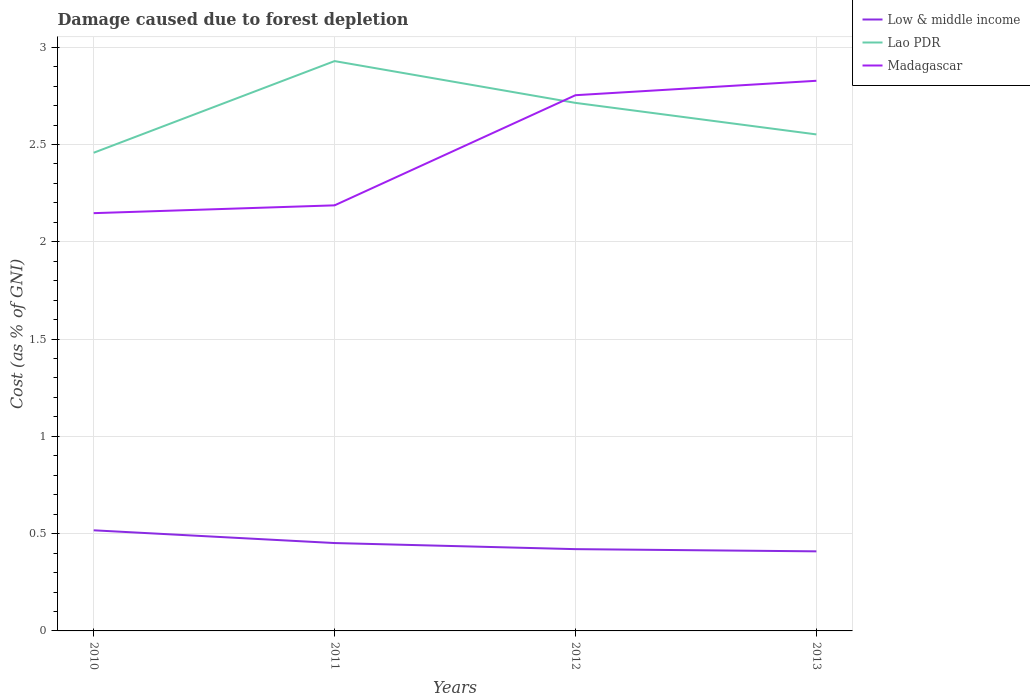How many different coloured lines are there?
Your response must be concise. 3. Does the line corresponding to Low & middle income intersect with the line corresponding to Madagascar?
Give a very brief answer. No. Is the number of lines equal to the number of legend labels?
Provide a short and direct response. Yes. Across all years, what is the maximum cost of damage caused due to forest depletion in Low & middle income?
Keep it short and to the point. 0.41. What is the total cost of damage caused due to forest depletion in Low & middle income in the graph?
Ensure brevity in your answer.  0.04. What is the difference between the highest and the second highest cost of damage caused due to forest depletion in Low & middle income?
Provide a succinct answer. 0.11. What is the difference between the highest and the lowest cost of damage caused due to forest depletion in Lao PDR?
Your answer should be compact. 2. Is the cost of damage caused due to forest depletion in Lao PDR strictly greater than the cost of damage caused due to forest depletion in Low & middle income over the years?
Keep it short and to the point. No. How many lines are there?
Keep it short and to the point. 3. What is the difference between two consecutive major ticks on the Y-axis?
Offer a terse response. 0.5. Does the graph contain grids?
Make the answer very short. Yes. Where does the legend appear in the graph?
Your answer should be very brief. Top right. How many legend labels are there?
Give a very brief answer. 3. What is the title of the graph?
Offer a terse response. Damage caused due to forest depletion. What is the label or title of the X-axis?
Your response must be concise. Years. What is the label or title of the Y-axis?
Provide a succinct answer. Cost (as % of GNI). What is the Cost (as % of GNI) in Low & middle income in 2010?
Offer a very short reply. 0.52. What is the Cost (as % of GNI) of Lao PDR in 2010?
Your response must be concise. 2.46. What is the Cost (as % of GNI) in Madagascar in 2010?
Ensure brevity in your answer.  2.15. What is the Cost (as % of GNI) in Low & middle income in 2011?
Provide a succinct answer. 0.45. What is the Cost (as % of GNI) in Lao PDR in 2011?
Your response must be concise. 2.93. What is the Cost (as % of GNI) of Madagascar in 2011?
Your answer should be very brief. 2.19. What is the Cost (as % of GNI) of Low & middle income in 2012?
Give a very brief answer. 0.42. What is the Cost (as % of GNI) of Lao PDR in 2012?
Offer a terse response. 2.71. What is the Cost (as % of GNI) in Madagascar in 2012?
Give a very brief answer. 2.75. What is the Cost (as % of GNI) in Low & middle income in 2013?
Ensure brevity in your answer.  0.41. What is the Cost (as % of GNI) of Lao PDR in 2013?
Your answer should be very brief. 2.55. What is the Cost (as % of GNI) of Madagascar in 2013?
Provide a short and direct response. 2.83. Across all years, what is the maximum Cost (as % of GNI) of Low & middle income?
Offer a very short reply. 0.52. Across all years, what is the maximum Cost (as % of GNI) of Lao PDR?
Give a very brief answer. 2.93. Across all years, what is the maximum Cost (as % of GNI) in Madagascar?
Your response must be concise. 2.83. Across all years, what is the minimum Cost (as % of GNI) in Low & middle income?
Your answer should be compact. 0.41. Across all years, what is the minimum Cost (as % of GNI) of Lao PDR?
Give a very brief answer. 2.46. Across all years, what is the minimum Cost (as % of GNI) of Madagascar?
Keep it short and to the point. 2.15. What is the total Cost (as % of GNI) in Low & middle income in the graph?
Ensure brevity in your answer.  1.8. What is the total Cost (as % of GNI) in Lao PDR in the graph?
Offer a very short reply. 10.65. What is the total Cost (as % of GNI) in Madagascar in the graph?
Provide a short and direct response. 9.92. What is the difference between the Cost (as % of GNI) in Low & middle income in 2010 and that in 2011?
Give a very brief answer. 0.07. What is the difference between the Cost (as % of GNI) of Lao PDR in 2010 and that in 2011?
Make the answer very short. -0.47. What is the difference between the Cost (as % of GNI) in Madagascar in 2010 and that in 2011?
Provide a short and direct response. -0.04. What is the difference between the Cost (as % of GNI) in Low & middle income in 2010 and that in 2012?
Make the answer very short. 0.1. What is the difference between the Cost (as % of GNI) of Lao PDR in 2010 and that in 2012?
Provide a short and direct response. -0.26. What is the difference between the Cost (as % of GNI) of Madagascar in 2010 and that in 2012?
Make the answer very short. -0.61. What is the difference between the Cost (as % of GNI) of Low & middle income in 2010 and that in 2013?
Give a very brief answer. 0.11. What is the difference between the Cost (as % of GNI) in Lao PDR in 2010 and that in 2013?
Your answer should be compact. -0.09. What is the difference between the Cost (as % of GNI) in Madagascar in 2010 and that in 2013?
Keep it short and to the point. -0.68. What is the difference between the Cost (as % of GNI) of Low & middle income in 2011 and that in 2012?
Your answer should be very brief. 0.03. What is the difference between the Cost (as % of GNI) of Lao PDR in 2011 and that in 2012?
Provide a succinct answer. 0.21. What is the difference between the Cost (as % of GNI) of Madagascar in 2011 and that in 2012?
Offer a terse response. -0.57. What is the difference between the Cost (as % of GNI) in Low & middle income in 2011 and that in 2013?
Your answer should be very brief. 0.04. What is the difference between the Cost (as % of GNI) in Lao PDR in 2011 and that in 2013?
Your response must be concise. 0.38. What is the difference between the Cost (as % of GNI) in Madagascar in 2011 and that in 2013?
Provide a succinct answer. -0.64. What is the difference between the Cost (as % of GNI) of Low & middle income in 2012 and that in 2013?
Ensure brevity in your answer.  0.01. What is the difference between the Cost (as % of GNI) of Lao PDR in 2012 and that in 2013?
Keep it short and to the point. 0.16. What is the difference between the Cost (as % of GNI) of Madagascar in 2012 and that in 2013?
Ensure brevity in your answer.  -0.07. What is the difference between the Cost (as % of GNI) of Low & middle income in 2010 and the Cost (as % of GNI) of Lao PDR in 2011?
Give a very brief answer. -2.41. What is the difference between the Cost (as % of GNI) in Low & middle income in 2010 and the Cost (as % of GNI) in Madagascar in 2011?
Make the answer very short. -1.67. What is the difference between the Cost (as % of GNI) in Lao PDR in 2010 and the Cost (as % of GNI) in Madagascar in 2011?
Provide a succinct answer. 0.27. What is the difference between the Cost (as % of GNI) of Low & middle income in 2010 and the Cost (as % of GNI) of Lao PDR in 2012?
Your answer should be very brief. -2.2. What is the difference between the Cost (as % of GNI) of Low & middle income in 2010 and the Cost (as % of GNI) of Madagascar in 2012?
Offer a very short reply. -2.24. What is the difference between the Cost (as % of GNI) of Lao PDR in 2010 and the Cost (as % of GNI) of Madagascar in 2012?
Offer a terse response. -0.3. What is the difference between the Cost (as % of GNI) in Low & middle income in 2010 and the Cost (as % of GNI) in Lao PDR in 2013?
Your response must be concise. -2.03. What is the difference between the Cost (as % of GNI) of Low & middle income in 2010 and the Cost (as % of GNI) of Madagascar in 2013?
Provide a short and direct response. -2.31. What is the difference between the Cost (as % of GNI) in Lao PDR in 2010 and the Cost (as % of GNI) in Madagascar in 2013?
Provide a succinct answer. -0.37. What is the difference between the Cost (as % of GNI) in Low & middle income in 2011 and the Cost (as % of GNI) in Lao PDR in 2012?
Provide a succinct answer. -2.26. What is the difference between the Cost (as % of GNI) in Low & middle income in 2011 and the Cost (as % of GNI) in Madagascar in 2012?
Give a very brief answer. -2.3. What is the difference between the Cost (as % of GNI) of Lao PDR in 2011 and the Cost (as % of GNI) of Madagascar in 2012?
Offer a very short reply. 0.18. What is the difference between the Cost (as % of GNI) in Low & middle income in 2011 and the Cost (as % of GNI) in Lao PDR in 2013?
Your answer should be compact. -2.1. What is the difference between the Cost (as % of GNI) in Low & middle income in 2011 and the Cost (as % of GNI) in Madagascar in 2013?
Provide a short and direct response. -2.38. What is the difference between the Cost (as % of GNI) in Lao PDR in 2011 and the Cost (as % of GNI) in Madagascar in 2013?
Ensure brevity in your answer.  0.1. What is the difference between the Cost (as % of GNI) in Low & middle income in 2012 and the Cost (as % of GNI) in Lao PDR in 2013?
Offer a terse response. -2.13. What is the difference between the Cost (as % of GNI) of Low & middle income in 2012 and the Cost (as % of GNI) of Madagascar in 2013?
Provide a succinct answer. -2.41. What is the difference between the Cost (as % of GNI) of Lao PDR in 2012 and the Cost (as % of GNI) of Madagascar in 2013?
Keep it short and to the point. -0.11. What is the average Cost (as % of GNI) in Low & middle income per year?
Provide a succinct answer. 0.45. What is the average Cost (as % of GNI) in Lao PDR per year?
Ensure brevity in your answer.  2.66. What is the average Cost (as % of GNI) of Madagascar per year?
Your response must be concise. 2.48. In the year 2010, what is the difference between the Cost (as % of GNI) in Low & middle income and Cost (as % of GNI) in Lao PDR?
Provide a short and direct response. -1.94. In the year 2010, what is the difference between the Cost (as % of GNI) of Low & middle income and Cost (as % of GNI) of Madagascar?
Provide a short and direct response. -1.63. In the year 2010, what is the difference between the Cost (as % of GNI) of Lao PDR and Cost (as % of GNI) of Madagascar?
Your answer should be very brief. 0.31. In the year 2011, what is the difference between the Cost (as % of GNI) in Low & middle income and Cost (as % of GNI) in Lao PDR?
Your answer should be compact. -2.48. In the year 2011, what is the difference between the Cost (as % of GNI) of Low & middle income and Cost (as % of GNI) of Madagascar?
Offer a terse response. -1.74. In the year 2011, what is the difference between the Cost (as % of GNI) of Lao PDR and Cost (as % of GNI) of Madagascar?
Provide a succinct answer. 0.74. In the year 2012, what is the difference between the Cost (as % of GNI) of Low & middle income and Cost (as % of GNI) of Lao PDR?
Provide a short and direct response. -2.29. In the year 2012, what is the difference between the Cost (as % of GNI) in Low & middle income and Cost (as % of GNI) in Madagascar?
Your response must be concise. -2.33. In the year 2012, what is the difference between the Cost (as % of GNI) of Lao PDR and Cost (as % of GNI) of Madagascar?
Your response must be concise. -0.04. In the year 2013, what is the difference between the Cost (as % of GNI) of Low & middle income and Cost (as % of GNI) of Lao PDR?
Your answer should be compact. -2.14. In the year 2013, what is the difference between the Cost (as % of GNI) of Low & middle income and Cost (as % of GNI) of Madagascar?
Your answer should be very brief. -2.42. In the year 2013, what is the difference between the Cost (as % of GNI) of Lao PDR and Cost (as % of GNI) of Madagascar?
Provide a succinct answer. -0.28. What is the ratio of the Cost (as % of GNI) of Low & middle income in 2010 to that in 2011?
Give a very brief answer. 1.15. What is the ratio of the Cost (as % of GNI) in Lao PDR in 2010 to that in 2011?
Your response must be concise. 0.84. What is the ratio of the Cost (as % of GNI) of Madagascar in 2010 to that in 2011?
Offer a very short reply. 0.98. What is the ratio of the Cost (as % of GNI) in Low & middle income in 2010 to that in 2012?
Offer a very short reply. 1.23. What is the ratio of the Cost (as % of GNI) of Lao PDR in 2010 to that in 2012?
Give a very brief answer. 0.91. What is the ratio of the Cost (as % of GNI) in Madagascar in 2010 to that in 2012?
Your answer should be very brief. 0.78. What is the ratio of the Cost (as % of GNI) in Low & middle income in 2010 to that in 2013?
Offer a terse response. 1.26. What is the ratio of the Cost (as % of GNI) in Lao PDR in 2010 to that in 2013?
Offer a very short reply. 0.96. What is the ratio of the Cost (as % of GNI) in Madagascar in 2010 to that in 2013?
Give a very brief answer. 0.76. What is the ratio of the Cost (as % of GNI) of Low & middle income in 2011 to that in 2012?
Keep it short and to the point. 1.07. What is the ratio of the Cost (as % of GNI) of Lao PDR in 2011 to that in 2012?
Keep it short and to the point. 1.08. What is the ratio of the Cost (as % of GNI) of Madagascar in 2011 to that in 2012?
Provide a short and direct response. 0.79. What is the ratio of the Cost (as % of GNI) in Low & middle income in 2011 to that in 2013?
Make the answer very short. 1.1. What is the ratio of the Cost (as % of GNI) of Lao PDR in 2011 to that in 2013?
Provide a short and direct response. 1.15. What is the ratio of the Cost (as % of GNI) in Madagascar in 2011 to that in 2013?
Provide a short and direct response. 0.77. What is the ratio of the Cost (as % of GNI) of Low & middle income in 2012 to that in 2013?
Your response must be concise. 1.03. What is the ratio of the Cost (as % of GNI) in Lao PDR in 2012 to that in 2013?
Ensure brevity in your answer.  1.06. What is the ratio of the Cost (as % of GNI) in Madagascar in 2012 to that in 2013?
Keep it short and to the point. 0.97. What is the difference between the highest and the second highest Cost (as % of GNI) of Low & middle income?
Your answer should be very brief. 0.07. What is the difference between the highest and the second highest Cost (as % of GNI) of Lao PDR?
Provide a short and direct response. 0.21. What is the difference between the highest and the second highest Cost (as % of GNI) in Madagascar?
Keep it short and to the point. 0.07. What is the difference between the highest and the lowest Cost (as % of GNI) in Low & middle income?
Provide a short and direct response. 0.11. What is the difference between the highest and the lowest Cost (as % of GNI) of Lao PDR?
Provide a short and direct response. 0.47. What is the difference between the highest and the lowest Cost (as % of GNI) in Madagascar?
Give a very brief answer. 0.68. 